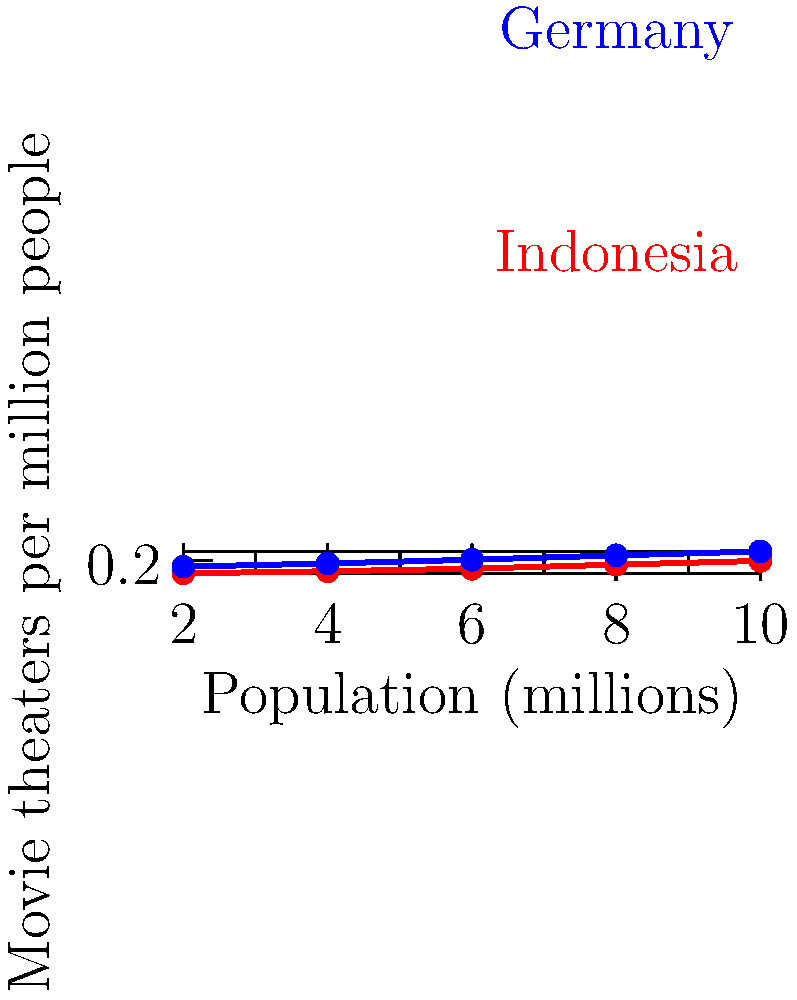Based on the scatter plot comparing the number of movie theaters per capita in Indonesia and Germany, what conclusion can you draw about the cinema infrastructure in these two countries? How might this relate to your experiences as an Indonesian film lover who recently visited Berlin? To analyze the scatter plot and draw conclusions, let's follow these steps:

1. Identify the axes:
   - X-axis: Population (in millions)
   - Y-axis: Movie theaters per million people

2. Observe the data points:
   - Red points represent Indonesia
   - Blue points represent Germany

3. Compare the trends:
   - Indonesia's data points are consistently lower on the Y-axis
   - Germany's data points are consistently higher on the Y-axis

4. Interpret the data:
   - For any given population size, Germany has more movie theaters per million people than Indonesia
   - This suggests that Germany has a more developed cinema infrastructure compared to Indonesia

5. Consider the implications:
   - More theaters per capita in Germany likely means:
     a. Greater accessibility to cinema
     b. More diverse film offerings
     c. Potentially more support for both mainstream and independent films

6. Relate to personal experience:
   - As an Indonesian film lover who visited Berlin, you might have noticed:
     a. More movie theaters in Berlin compared to similarly sized Indonesian cities
     b. A wider variety of films available in German theaters
     c. Potentially more screenings of international and arthouse films

7. Conclusion:
   The data shows that Germany has a higher density of movie theaters per capita compared to Indonesia, indicating a more developed cinema infrastructure. This aligns with the experience of an Indonesian film enthusiast visiting Berlin, who would likely notice more numerous and diverse cinema options.
Answer: Germany has a higher density of movie theaters per capita than Indonesia, indicating a more developed cinema infrastructure. 